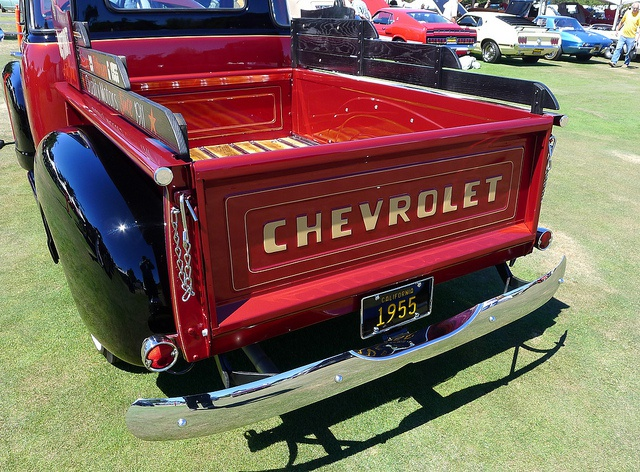Describe the objects in this image and their specific colors. I can see truck in lightblue, black, maroon, brown, and darkgray tones, car in lightblue, white, black, gray, and darkgray tones, car in lightblue, salmon, lavender, and black tones, car in lightblue, black, and white tones, and people in lightblue, ivory, khaki, and darkgray tones in this image. 